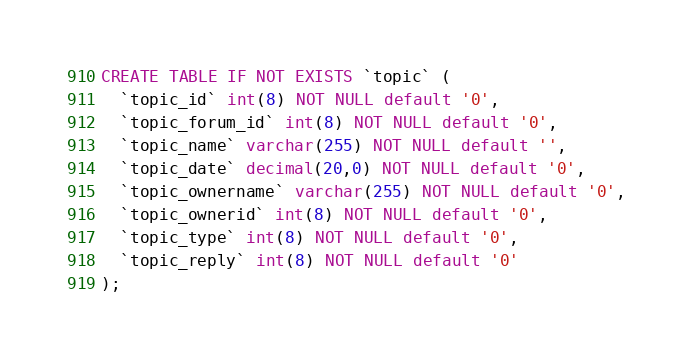<code> <loc_0><loc_0><loc_500><loc_500><_SQL_>CREATE TABLE IF NOT EXISTS `topic` (
  `topic_id` int(8) NOT NULL default '0',
  `topic_forum_id` int(8) NOT NULL default '0',
  `topic_name` varchar(255) NOT NULL default '',
  `topic_date` decimal(20,0) NOT NULL default '0',
  `topic_ownername` varchar(255) NOT NULL default '0',
  `topic_ownerid` int(8) NOT NULL default '0',
  `topic_type` int(8) NOT NULL default '0',
  `topic_reply` int(8) NOT NULL default '0'
);</code> 